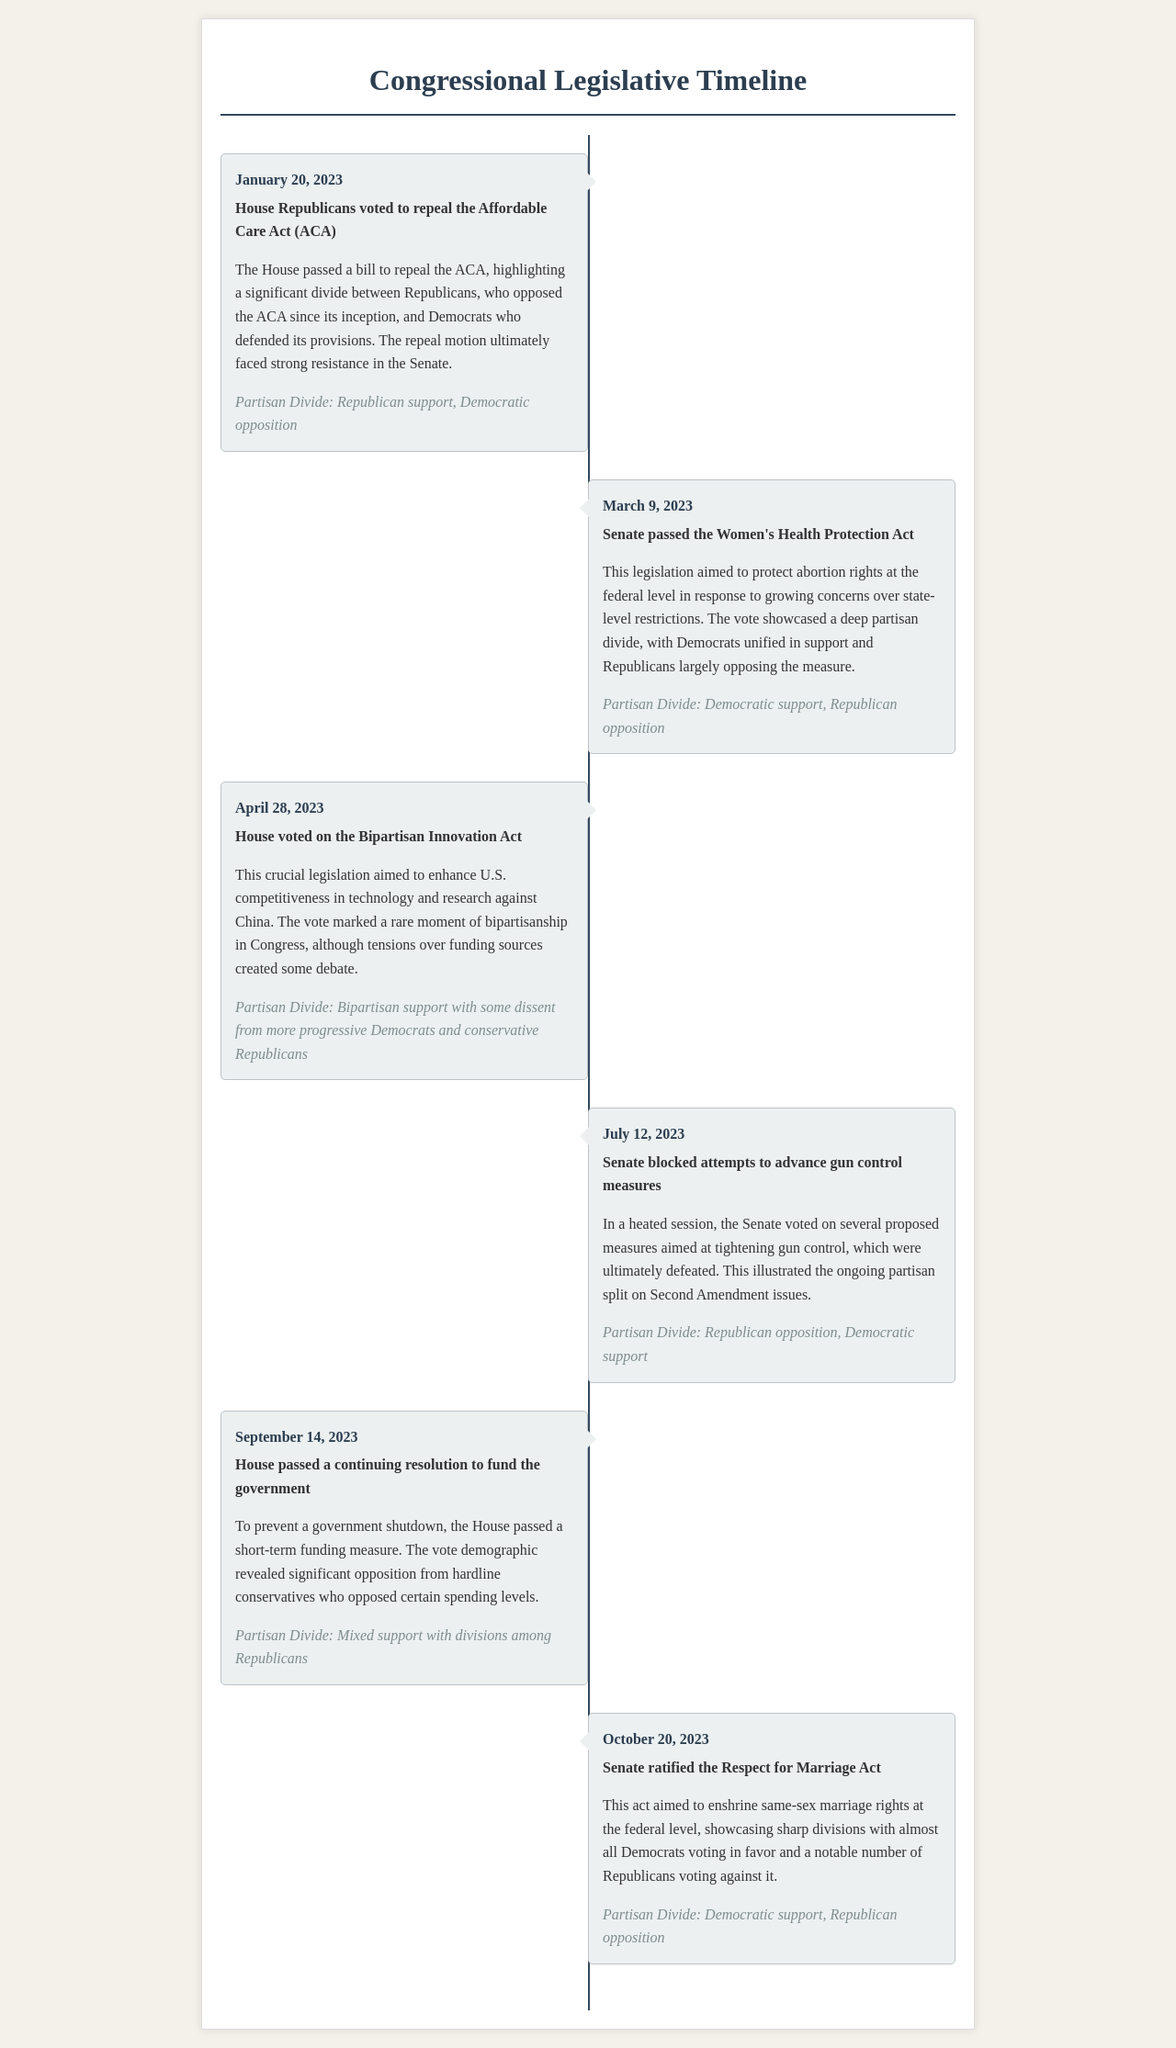What was the date of the vote to repeal the Affordable Care Act? The date of the vote to repeal the Affordable Care Act is mentioned in the event details as January 20, 2023.
Answer: January 20, 2023 What act did the Senate pass on March 9, 2023? It specifies that the Senate passed the Women's Health Protection Act on that date.
Answer: Women's Health Protection Act Which party predominantly opposed the Bipartisan Innovation Act? The document notes some dissent from conservative Republicans, indicating they were among the opponents.
Answer: Conservative Republicans How many significant votes are detailed in the timeline? The timeline lists a total of six significant votes across various dates.
Answer: Six Which legislative act supports same-sex marriage rights? The document names the Respect for Marriage Act as the legislation that enshrines same-sex marriage rights at the federal level.
Answer: Respect for Marriage Act What was a key issue during the vote on gun control measures on July 12, 2023? The document highlights that there was a partisan split on Second Amendment issues during the gun control measures vote.
Answer: Second Amendment issues What was the outcome of the House's vote on the continuing resolution on September 14, 2023? It mentions that the House passed a short-term funding measure to prevent a government shutdown.
Answer: Passed Which party showed unified support for the Women's Health Protection Act? The document indicates that Democrats were unified in support of this act.
Answer: Democrats 